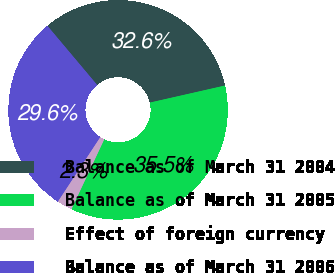Convert chart. <chart><loc_0><loc_0><loc_500><loc_500><pie_chart><fcel>Balance as of March 31 2004<fcel>Balance as of March 31 2005<fcel>Effect of foreign currency<fcel>Balance as of March 31 2006<nl><fcel>32.58%<fcel>35.54%<fcel>2.27%<fcel>29.62%<nl></chart> 